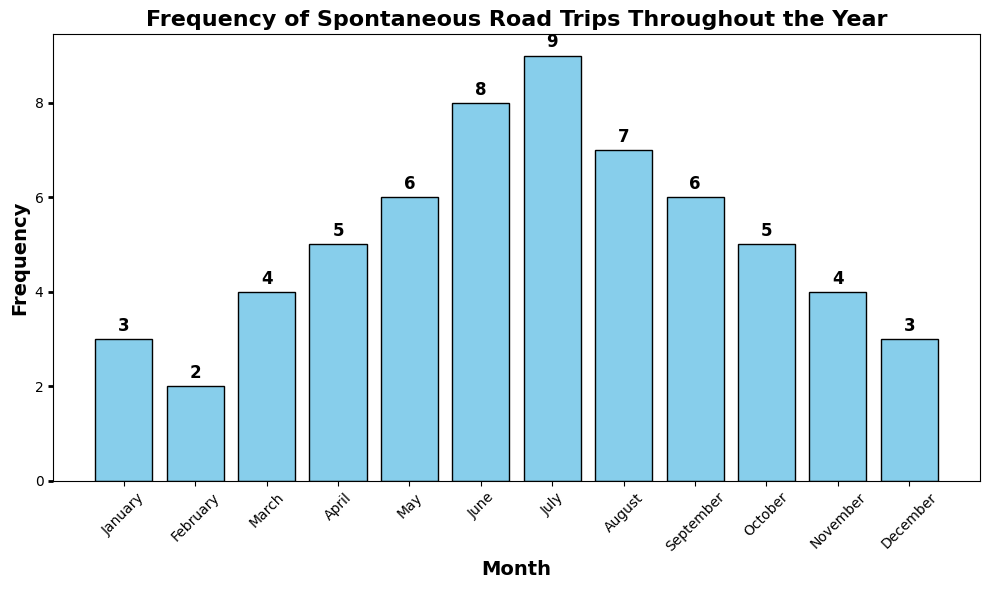What's the month with the highest frequency of spontaneous road trips? The month with the highest bar is July.
Answer: July Which months have the same frequency of spontaneous road trips? January and December both have a frequency of 3; May and September have a frequency of 6.
Answer: January and December; May and September What's the median frequency of spontaneous road trips? The frequencies in ascending order are: 2, 3, 3, 4, 4, 5, 5, 6, 6, 7, 8, 9. There are 12 data points, and the median is the average of the 6th and 7th values: (5 + 5) / 2 = 5.
Answer: 5 How many months have a frequency greater than 5? The months with a frequency greater than 5 are June, July, and August, making a total of 3 months.
Answer: 3 How much higher is the frequency in July compared to February? The frequency in July is 9, and in February it is 2. The difference is 9 - 2 = 7.
Answer: 7 Which quarter of the year has the highest total frequency of spontaneous road trips? The quarters are:
Q1: January, February, March (3+2+4=9)
Q2: April, May, June (5+6+8=19)
Q3: July, August, September (9+7+6=22)
Q4: October, November, December (5+4+3=12)
Q3 has the highest total frequency of 22.
Answer: Q3 What is the average frequency of spontaneous road trips across all months? The sum of all frequencies is 3+2+4+5+6+8+9+7+6+5+4+3=62. The average is 62/12 ≈ 5.17.
Answer: 5.17 Is the frequency in April higher or lower than the average frequency? The frequency in April is 5. The average frequency is approximately 5.17, so April's frequency is lower.
Answer: Lower What's the difference in frequency between the months with the highest and lowest frequencies? The highest frequency is in July (9) and the lowest is in February (2). The difference is 9 - 2 = 7.
Answer: 7 